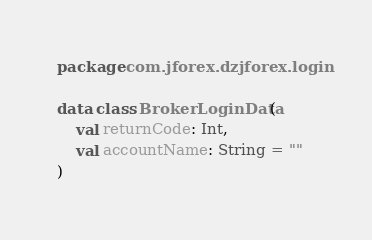<code> <loc_0><loc_0><loc_500><loc_500><_Kotlin_>package com.jforex.dzjforex.login

data class BrokerLoginData(
    val returnCode: Int,
    val accountName: String = ""
)</code> 